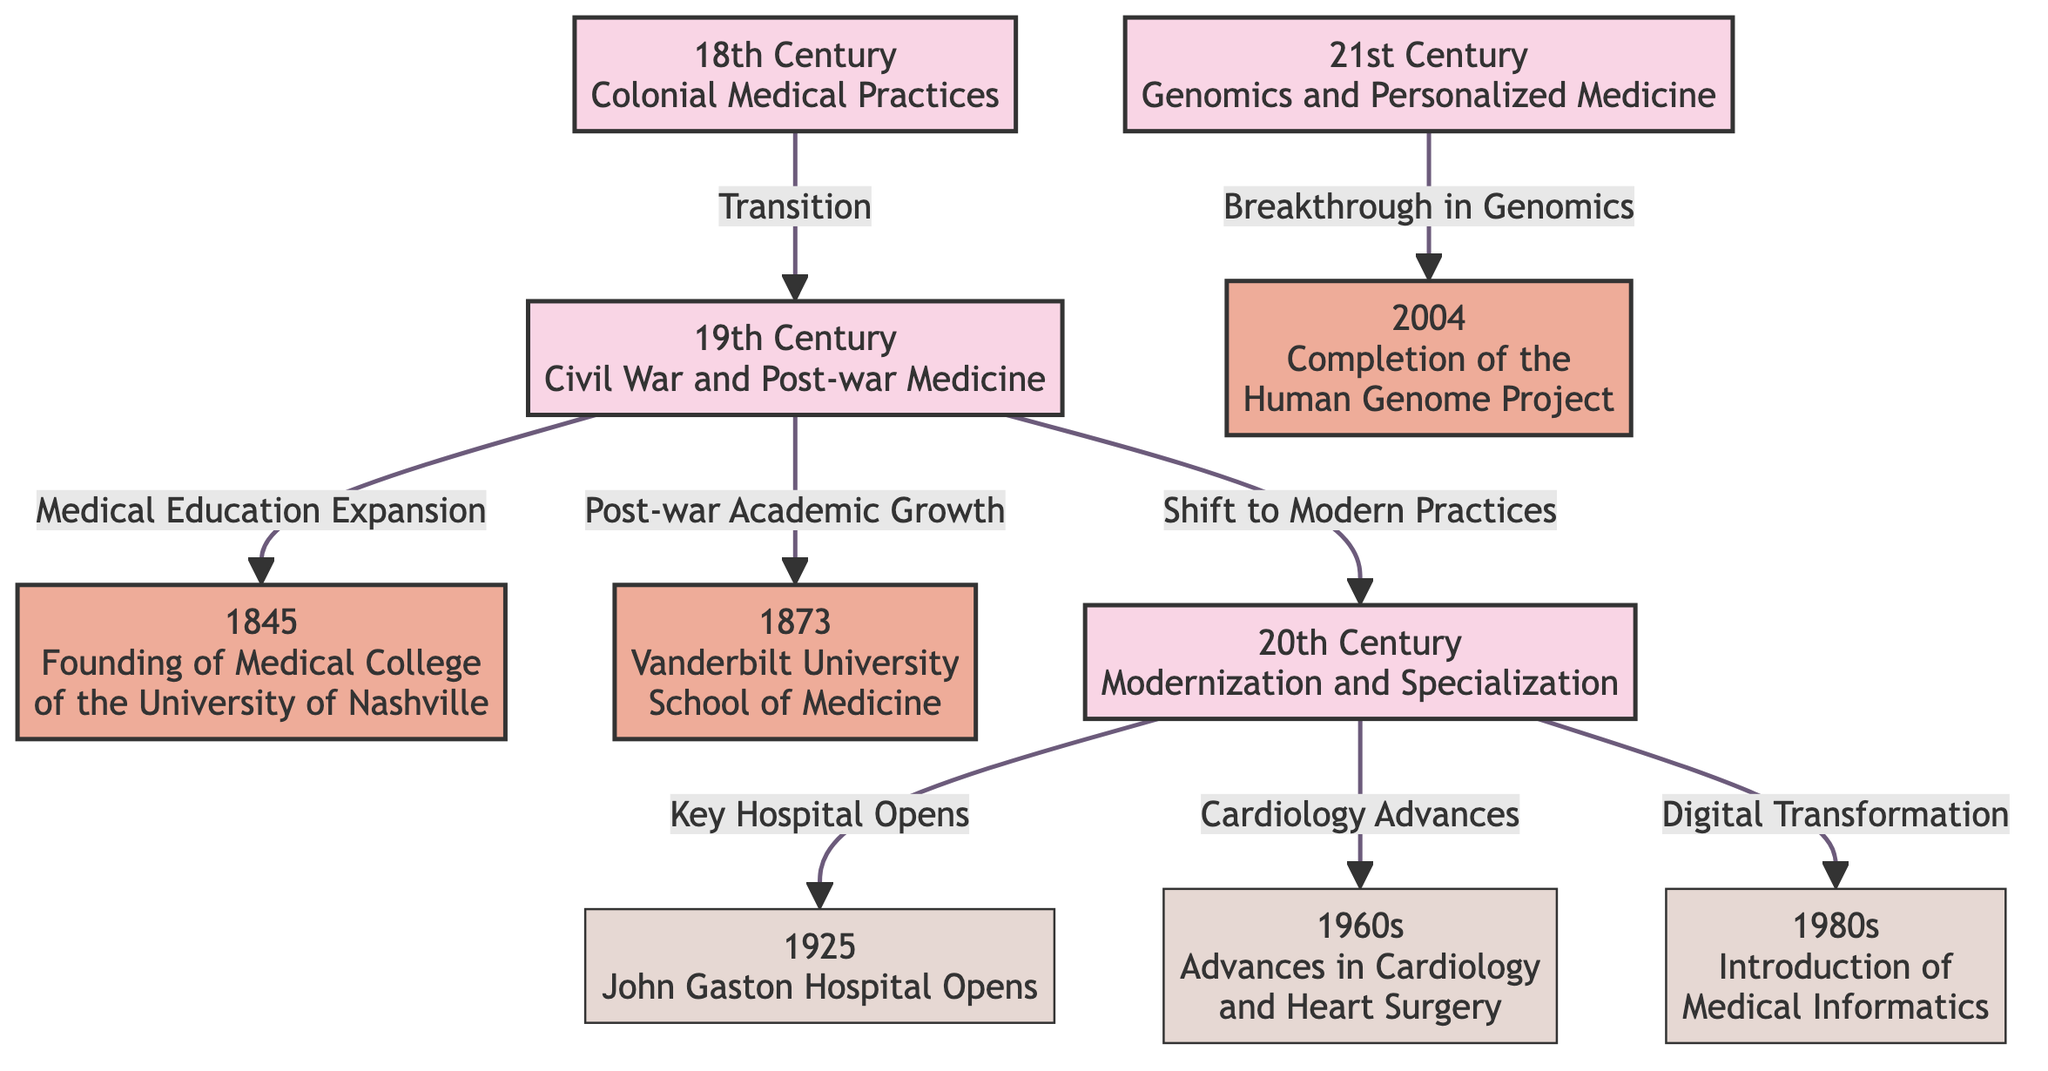What milestone marks the founding of the Medical College of the University of Nashville? The diagram indicates that the founding year of the Medical College of the University of Nashville is 1845, which is a milestone in the 19th century section. Therefore, the answer is based on the node associated with this event.
Answer: 1845 Which event happened in 1925 according to the diagram? The diagram lists the opening of John Gaston Hospital in 1925 as an event in the 20th century section. This information is represented in a specific node that indicates this occurrence.
Answer: John Gaston Hospital Opens What decade is highlighted for advances in cardiology? The diagram specifies the 1960s for advances in cardiology and heart surgery. This is connected to the events listed in the 20th century section. The answer is derived from identifying the relevant node linked to this event.
Answer: 1960s How many major milestones are identified in the diagram? By analyzing the diagram, we observe three major milestones indicated by nodes in the flowchart: the founding of the Medical College in 1845, the opening of Vanderbilt University School of Medicine in 1873, and the completion of the Human Genome Project in 2004. Counting these nodes gives the total number of milestones.
Answer: 3 What is the primary focus of the 21st century in the diagram? The diagram indicates that the primary focus of the 21st century is on genomics and personalized medicine. This information is found in the node describing the 21st century, which summarizes key developments of that era.
Answer: Genomics and Personalized Medicine How did the 19th century influence the transition to the 20th century? The diagram shows a connection where the 19th century's medical education expansion and post-war academic growth contributed to the shift to modern practices in the 20th century. This relationship is represented through directional arrows indicating the flow from one node to another.
Answer: Shift to Modern Practices What significant project was completed in 2004? According to the diagram, the significant project completed in 2004 was the Human Genome Project. This milestone is indicated clearly in the section representing the 21st century.
Answer: Completion of the Human Genome Project What major development occurred during the 1980s? The diagram identifies the introduction of medical informatics as a major development in the 1980s. This is connected to the 20th century nodes where modern practices began to take shape.
Answer: Introduction of Medical Informatics 